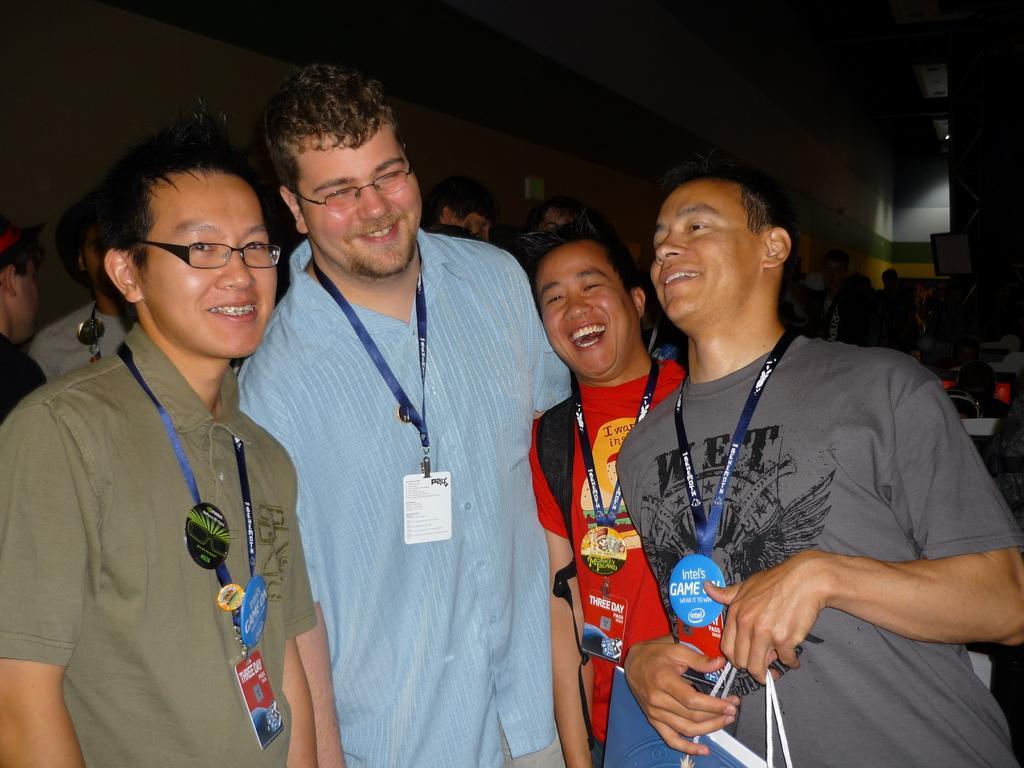Can you describe this image briefly? In this image there are group of persons standing, there are persons truncated towards the bottom of the image, there is a person holding an object, there is an object truncated towards the bottom of the image, there are persons truncated towards the left of the image, there are persons truncated towards the right of the image, there is the wall truncated towards the right of the image, there is the wall truncated towards the left of the image, there is the wall truncated towards the top of the image, there is the roof truncated towards the top of the image, there are objects on the wall. 